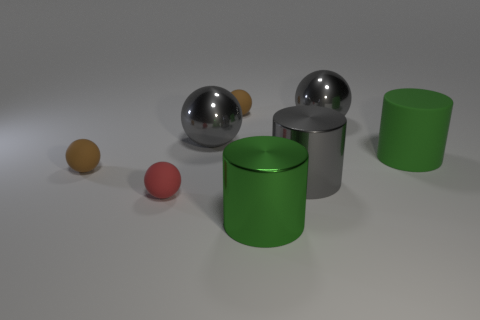Subtract all red balls. How many balls are left? 4 Subtract all red rubber balls. How many balls are left? 4 Subtract all purple spheres. Subtract all blue cylinders. How many spheres are left? 5 Add 1 tiny cyan metallic blocks. How many objects exist? 9 Subtract all cylinders. How many objects are left? 5 Subtract 0 green blocks. How many objects are left? 8 Subtract all small cyan rubber cubes. Subtract all small brown things. How many objects are left? 6 Add 4 big green things. How many big green things are left? 6 Add 5 cylinders. How many cylinders exist? 8 